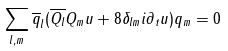<formula> <loc_0><loc_0><loc_500><loc_500>\sum _ { l , m } \overline { q } _ { l } ( \overline { Q _ { l } } { Q _ { m } } u + 8 \delta _ { l m } i \partial _ { t } u ) { q } _ { m } = 0</formula> 